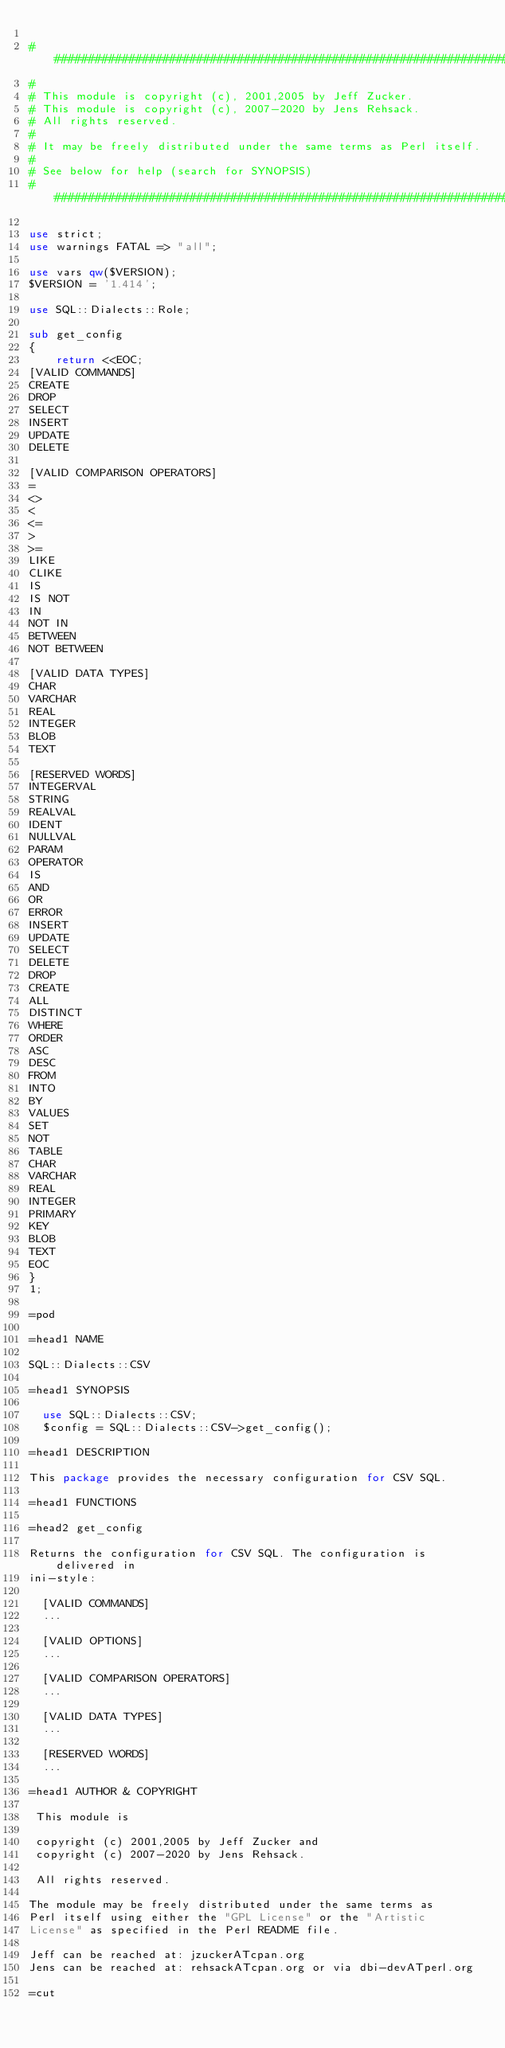<code> <loc_0><loc_0><loc_500><loc_500><_Perl_>
#########################################################################
#
# This module is copyright (c), 2001,2005 by Jeff Zucker.
# This module is copyright (c), 2007-2020 by Jens Rehsack.
# All rights reserved.
#
# It may be freely distributed under the same terms as Perl itself.
#
# See below for help (search for SYNOPSIS)
#########################################################################

use strict;
use warnings FATAL => "all";

use vars qw($VERSION);
$VERSION = '1.414';

use SQL::Dialects::Role;

sub get_config
{
    return <<EOC;
[VALID COMMANDS]
CREATE
DROP
SELECT
INSERT
UPDATE
DELETE

[VALID COMPARISON OPERATORS]
=
<>
<
<=
>
>=
LIKE
CLIKE
IS
IS NOT
IN
NOT IN
BETWEEN
NOT BETWEEN

[VALID DATA TYPES]
CHAR
VARCHAR
REAL
INTEGER
BLOB
TEXT

[RESERVED WORDS]
INTEGERVAL
STRING
REALVAL
IDENT
NULLVAL
PARAM
OPERATOR
IS
AND
OR
ERROR
INSERT
UPDATE
SELECT
DELETE
DROP
CREATE
ALL
DISTINCT
WHERE
ORDER
ASC
DESC
FROM
INTO
BY
VALUES
SET
NOT
TABLE
CHAR
VARCHAR
REAL
INTEGER
PRIMARY
KEY
BLOB
TEXT
EOC
}
1;

=pod

=head1 NAME

SQL::Dialects::CSV

=head1 SYNOPSIS

  use SQL::Dialects::CSV;
  $config = SQL::Dialects::CSV->get_config();

=head1 DESCRIPTION

This package provides the necessary configuration for CSV SQL.

=head1 FUNCTIONS

=head2 get_config

Returns the configuration for CSV SQL. The configuration is delivered in
ini-style:

  [VALID COMMANDS]
  ...

  [VALID OPTIONS]
  ...

  [VALID COMPARISON OPERATORS]
  ...

  [VALID DATA TYPES]
  ...

  [RESERVED WORDS]
  ...

=head1 AUTHOR & COPYRIGHT

 This module is

 copyright (c) 2001,2005 by Jeff Zucker and
 copyright (c) 2007-2020 by Jens Rehsack.

 All rights reserved.

The module may be freely distributed under the same terms as
Perl itself using either the "GPL License" or the "Artistic
License" as specified in the Perl README file.

Jeff can be reached at: jzuckerATcpan.org
Jens can be reached at: rehsackATcpan.org or via dbi-devATperl.org

=cut
</code> 